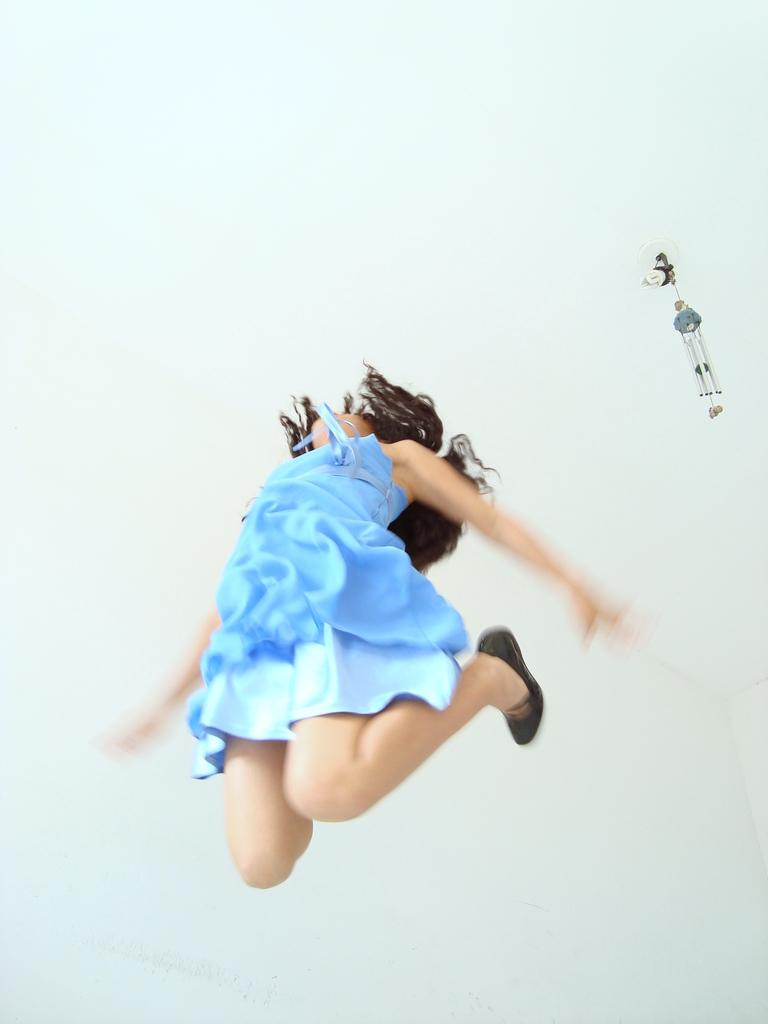Who is the main subject in the image? There is a girl in the image. What is the girl doing in the image? The girl is jumping. What can be seen on the right side of the image? There is an object on the right side of the image. What is visible in the background of the image? There is a wall in the background of the image. What type of crate is being used as a prop in the image? There is no crate present in the image. Is the girl in the image being held in a jail? There is no indication of a jail or any confinement in the image; the girl is simply jumping. 